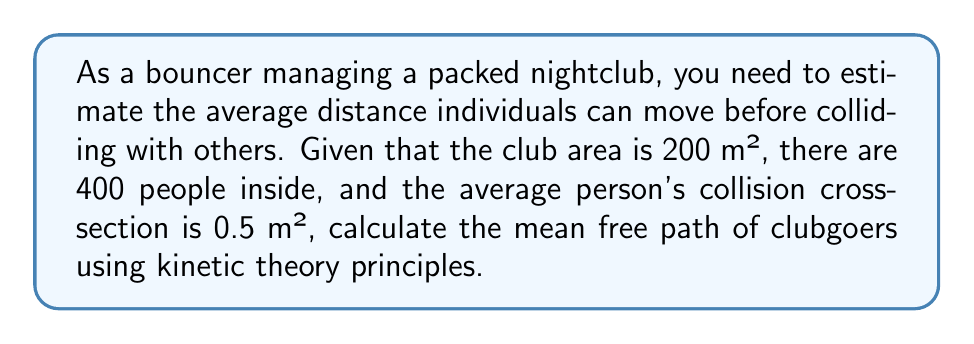Provide a solution to this math problem. To solve this problem, we'll use the kinetic theory formula for mean free path:

$$ \lambda = \frac{1}{n\sigma} $$

Where:
$\lambda$ = mean free path
$n$ = number density of people
$\sigma$ = collision cross-section

Step 1: Calculate the number density (n)
$$ n = \frac{\text{Number of people}}{\text{Area}} = \frac{400}{200 \text{ m}^2} = 2 \text{ people/m}^2 $$

Step 2: Use the given collision cross-section
$\sigma = 0.5 \text{ m}^2$

Step 3: Apply the mean free path formula
$$ \lambda = \frac{1}{n\sigma} = \frac{1}{(2 \text{ people/m}^2)(0.5 \text{ m}^2)} = 1 \text{ m} $$

Thus, the mean free path of clubgoers is 1 meter.
Answer: 1 m 